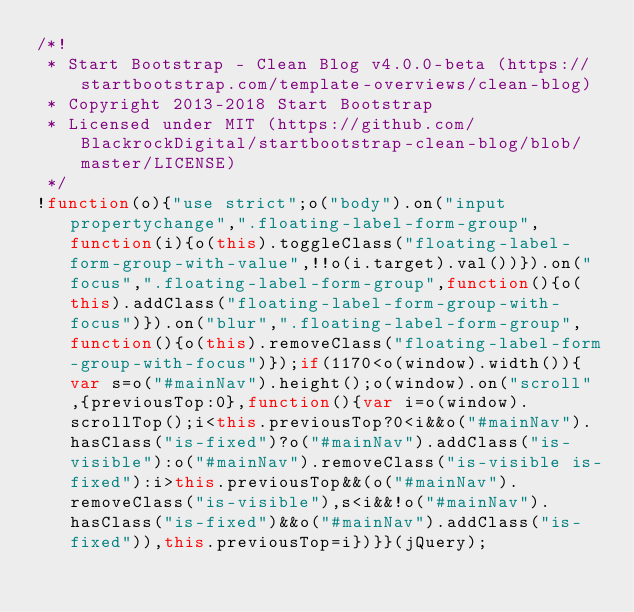<code> <loc_0><loc_0><loc_500><loc_500><_JavaScript_>/*!
 * Start Bootstrap - Clean Blog v4.0.0-beta (https://startbootstrap.com/template-overviews/clean-blog)
 * Copyright 2013-2018 Start Bootstrap
 * Licensed under MIT (https://github.com/BlackrockDigital/startbootstrap-clean-blog/blob/master/LICENSE)
 */
!function(o){"use strict";o("body").on("input propertychange",".floating-label-form-group",function(i){o(this).toggleClass("floating-label-form-group-with-value",!!o(i.target).val())}).on("focus",".floating-label-form-group",function(){o(this).addClass("floating-label-form-group-with-focus")}).on("blur",".floating-label-form-group",function(){o(this).removeClass("floating-label-form-group-with-focus")});if(1170<o(window).width()){var s=o("#mainNav").height();o(window).on("scroll",{previousTop:0},function(){var i=o(window).scrollTop();i<this.previousTop?0<i&&o("#mainNav").hasClass("is-fixed")?o("#mainNav").addClass("is-visible"):o("#mainNav").removeClass("is-visible is-fixed"):i>this.previousTop&&(o("#mainNav").removeClass("is-visible"),s<i&&!o("#mainNav").hasClass("is-fixed")&&o("#mainNav").addClass("is-fixed")),this.previousTop=i})}}(jQuery);</code> 